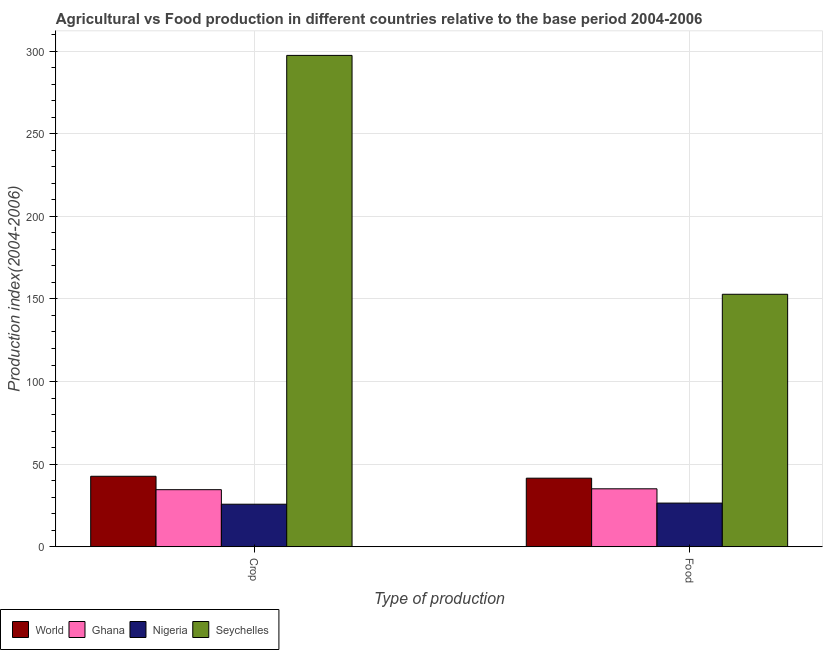How many different coloured bars are there?
Your response must be concise. 4. How many groups of bars are there?
Provide a succinct answer. 2. How many bars are there on the 1st tick from the right?
Your answer should be compact. 4. What is the label of the 2nd group of bars from the left?
Ensure brevity in your answer.  Food. What is the crop production index in Nigeria?
Ensure brevity in your answer.  25.75. Across all countries, what is the maximum crop production index?
Your answer should be compact. 297.41. Across all countries, what is the minimum food production index?
Your answer should be very brief. 26.43. In which country was the food production index maximum?
Keep it short and to the point. Seychelles. In which country was the crop production index minimum?
Provide a short and direct response. Nigeria. What is the total food production index in the graph?
Provide a succinct answer. 255.83. What is the difference between the crop production index in World and that in Nigeria?
Keep it short and to the point. 16.91. What is the difference between the food production index in Ghana and the crop production index in World?
Keep it short and to the point. -7.58. What is the average crop production index per country?
Make the answer very short. 100.09. What is the difference between the food production index and crop production index in World?
Provide a short and direct response. -1.15. In how many countries, is the crop production index greater than 110 ?
Give a very brief answer. 1. What is the ratio of the food production index in World to that in Seychelles?
Make the answer very short. 0.27. In how many countries, is the food production index greater than the average food production index taken over all countries?
Your answer should be compact. 1. What does the 4th bar from the left in Crop represents?
Your response must be concise. Seychelles. What does the 1st bar from the right in Crop represents?
Give a very brief answer. Seychelles. How many bars are there?
Provide a short and direct response. 8. How many countries are there in the graph?
Your answer should be very brief. 4. Does the graph contain any zero values?
Keep it short and to the point. No. How many legend labels are there?
Offer a terse response. 4. What is the title of the graph?
Your answer should be very brief. Agricultural vs Food production in different countries relative to the base period 2004-2006. Does "Peru" appear as one of the legend labels in the graph?
Keep it short and to the point. No. What is the label or title of the X-axis?
Your response must be concise. Type of production. What is the label or title of the Y-axis?
Your response must be concise. Production index(2004-2006). What is the Production index(2004-2006) of World in Crop?
Keep it short and to the point. 42.66. What is the Production index(2004-2006) of Ghana in Crop?
Keep it short and to the point. 34.55. What is the Production index(2004-2006) in Nigeria in Crop?
Ensure brevity in your answer.  25.75. What is the Production index(2004-2006) of Seychelles in Crop?
Your response must be concise. 297.41. What is the Production index(2004-2006) in World in Food?
Offer a terse response. 41.5. What is the Production index(2004-2006) in Ghana in Food?
Offer a terse response. 35.08. What is the Production index(2004-2006) of Nigeria in Food?
Provide a short and direct response. 26.43. What is the Production index(2004-2006) of Seychelles in Food?
Make the answer very short. 152.82. Across all Type of production, what is the maximum Production index(2004-2006) in World?
Your response must be concise. 42.66. Across all Type of production, what is the maximum Production index(2004-2006) in Ghana?
Offer a very short reply. 35.08. Across all Type of production, what is the maximum Production index(2004-2006) in Nigeria?
Offer a very short reply. 26.43. Across all Type of production, what is the maximum Production index(2004-2006) in Seychelles?
Provide a succinct answer. 297.41. Across all Type of production, what is the minimum Production index(2004-2006) in World?
Offer a terse response. 41.5. Across all Type of production, what is the minimum Production index(2004-2006) in Ghana?
Make the answer very short. 34.55. Across all Type of production, what is the minimum Production index(2004-2006) in Nigeria?
Give a very brief answer. 25.75. Across all Type of production, what is the minimum Production index(2004-2006) of Seychelles?
Your response must be concise. 152.82. What is the total Production index(2004-2006) in World in the graph?
Your answer should be very brief. 84.16. What is the total Production index(2004-2006) of Ghana in the graph?
Offer a very short reply. 69.63. What is the total Production index(2004-2006) of Nigeria in the graph?
Provide a succinct answer. 52.18. What is the total Production index(2004-2006) of Seychelles in the graph?
Offer a terse response. 450.23. What is the difference between the Production index(2004-2006) in World in Crop and that in Food?
Keep it short and to the point. 1.15. What is the difference between the Production index(2004-2006) of Ghana in Crop and that in Food?
Ensure brevity in your answer.  -0.53. What is the difference between the Production index(2004-2006) of Nigeria in Crop and that in Food?
Keep it short and to the point. -0.68. What is the difference between the Production index(2004-2006) of Seychelles in Crop and that in Food?
Give a very brief answer. 144.59. What is the difference between the Production index(2004-2006) in World in Crop and the Production index(2004-2006) in Ghana in Food?
Ensure brevity in your answer.  7.58. What is the difference between the Production index(2004-2006) of World in Crop and the Production index(2004-2006) of Nigeria in Food?
Provide a succinct answer. 16.23. What is the difference between the Production index(2004-2006) in World in Crop and the Production index(2004-2006) in Seychelles in Food?
Provide a short and direct response. -110.16. What is the difference between the Production index(2004-2006) in Ghana in Crop and the Production index(2004-2006) in Nigeria in Food?
Provide a succinct answer. 8.12. What is the difference between the Production index(2004-2006) of Ghana in Crop and the Production index(2004-2006) of Seychelles in Food?
Make the answer very short. -118.27. What is the difference between the Production index(2004-2006) of Nigeria in Crop and the Production index(2004-2006) of Seychelles in Food?
Your answer should be very brief. -127.07. What is the average Production index(2004-2006) in World per Type of production?
Provide a short and direct response. 42.08. What is the average Production index(2004-2006) in Ghana per Type of production?
Ensure brevity in your answer.  34.81. What is the average Production index(2004-2006) in Nigeria per Type of production?
Your answer should be very brief. 26.09. What is the average Production index(2004-2006) in Seychelles per Type of production?
Make the answer very short. 225.12. What is the difference between the Production index(2004-2006) in World and Production index(2004-2006) in Ghana in Crop?
Offer a terse response. 8.11. What is the difference between the Production index(2004-2006) in World and Production index(2004-2006) in Nigeria in Crop?
Your answer should be very brief. 16.91. What is the difference between the Production index(2004-2006) in World and Production index(2004-2006) in Seychelles in Crop?
Provide a short and direct response. -254.75. What is the difference between the Production index(2004-2006) in Ghana and Production index(2004-2006) in Seychelles in Crop?
Give a very brief answer. -262.86. What is the difference between the Production index(2004-2006) in Nigeria and Production index(2004-2006) in Seychelles in Crop?
Your answer should be compact. -271.66. What is the difference between the Production index(2004-2006) of World and Production index(2004-2006) of Ghana in Food?
Ensure brevity in your answer.  6.42. What is the difference between the Production index(2004-2006) in World and Production index(2004-2006) in Nigeria in Food?
Make the answer very short. 15.07. What is the difference between the Production index(2004-2006) in World and Production index(2004-2006) in Seychelles in Food?
Ensure brevity in your answer.  -111.32. What is the difference between the Production index(2004-2006) of Ghana and Production index(2004-2006) of Nigeria in Food?
Offer a very short reply. 8.65. What is the difference between the Production index(2004-2006) of Ghana and Production index(2004-2006) of Seychelles in Food?
Your response must be concise. -117.74. What is the difference between the Production index(2004-2006) in Nigeria and Production index(2004-2006) in Seychelles in Food?
Keep it short and to the point. -126.39. What is the ratio of the Production index(2004-2006) in World in Crop to that in Food?
Make the answer very short. 1.03. What is the ratio of the Production index(2004-2006) in Ghana in Crop to that in Food?
Ensure brevity in your answer.  0.98. What is the ratio of the Production index(2004-2006) of Nigeria in Crop to that in Food?
Provide a succinct answer. 0.97. What is the ratio of the Production index(2004-2006) in Seychelles in Crop to that in Food?
Your answer should be compact. 1.95. What is the difference between the highest and the second highest Production index(2004-2006) in World?
Ensure brevity in your answer.  1.15. What is the difference between the highest and the second highest Production index(2004-2006) in Ghana?
Make the answer very short. 0.53. What is the difference between the highest and the second highest Production index(2004-2006) of Nigeria?
Your response must be concise. 0.68. What is the difference between the highest and the second highest Production index(2004-2006) in Seychelles?
Give a very brief answer. 144.59. What is the difference between the highest and the lowest Production index(2004-2006) in World?
Give a very brief answer. 1.15. What is the difference between the highest and the lowest Production index(2004-2006) in Ghana?
Your response must be concise. 0.53. What is the difference between the highest and the lowest Production index(2004-2006) in Nigeria?
Make the answer very short. 0.68. What is the difference between the highest and the lowest Production index(2004-2006) in Seychelles?
Your answer should be very brief. 144.59. 